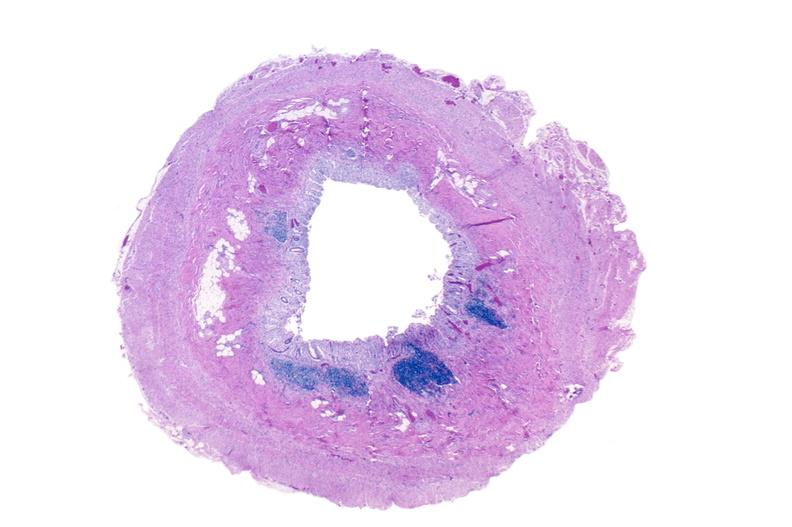s gastrointestinal present?
Answer the question using a single word or phrase. Yes 